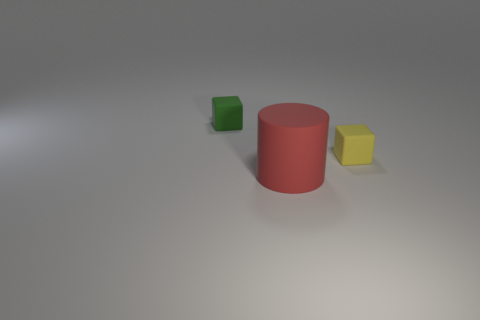Is there any other thing that is the same color as the big object?
Your response must be concise. No. Is the number of big objects on the right side of the small green object the same as the number of big red matte things that are left of the big rubber thing?
Make the answer very short. No. Are there more yellow rubber objects to the left of the big cylinder than tiny rubber blocks?
Your answer should be compact. No. What number of things are large red rubber cylinders that are in front of the yellow cube or yellow rubber cubes?
Your answer should be compact. 2. How many other tiny yellow things have the same material as the yellow object?
Provide a short and direct response. 0. Are there any tiny green things of the same shape as the red matte thing?
Offer a terse response. No. What shape is the object that is the same size as the green matte block?
Give a very brief answer. Cube. Does the big rubber cylinder have the same color as the tiny matte block that is to the left of the large thing?
Offer a terse response. No. How many tiny green rubber things are in front of the tiny rubber cube that is right of the small green matte thing?
Your answer should be very brief. 0. What size is the thing that is to the left of the small yellow rubber thing and behind the red cylinder?
Provide a short and direct response. Small. 